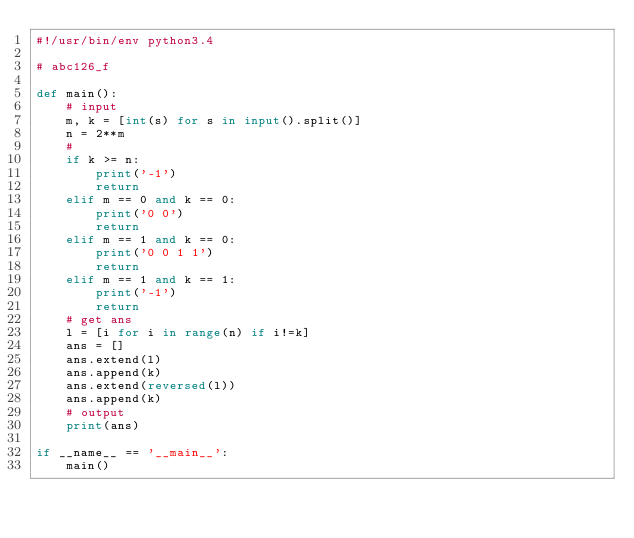Convert code to text. <code><loc_0><loc_0><loc_500><loc_500><_Python_>#!/usr/bin/env python3.4

# abc126_f

def main():
    # input
    m, k = [int(s) for s in input().split()]
    n = 2**m
    #
    if k >= n:
        print('-1')
        return
    elif m == 0 and k == 0:
        print('0 0')
        return
    elif m == 1 and k == 0:
        print('0 0 1 1')
        return
    elif m == 1 and k == 1:
        print('-1')
        return
    # get ans
    l = [i for i in range(n) if i!=k]
    ans = []
    ans.extend(l)
    ans.append(k)
    ans.extend(reversed(l))
    ans.append(k)
    # output
    print(ans)

if __name__ == '__main__':
    main()

</code> 